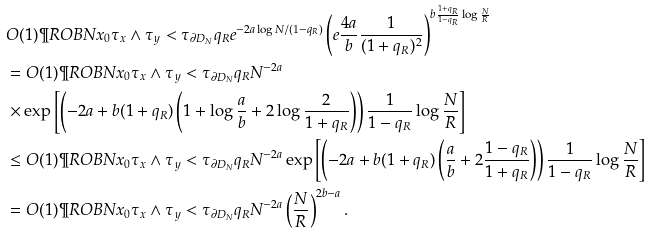<formula> <loc_0><loc_0><loc_500><loc_500>& O ( 1 ) \P R O B { N x _ { 0 } } { \tau _ { x } \wedge \tau _ { y } < \tau _ { \partial D _ { N } } } q _ { R } e ^ { - 2 a \log N / ( 1 - q _ { R } ) } \left ( e \frac { 4 a } { b } \frac { 1 } { ( 1 + q _ { R } ) ^ { 2 } } \right ) ^ { b \frac { 1 + q _ { R } } { 1 - q _ { R } } \log \frac { N } { R } } \\ & = O ( 1 ) \P R O B { N x _ { 0 } } { \tau _ { x } \wedge \tau _ { y } < \tau _ { \partial D _ { N } } } q _ { R } N ^ { - 2 a } \\ & \times \exp \left [ \left ( - 2 a + b ( 1 + q _ { R } ) \left ( 1 + \log \frac { a } { b } + 2 \log \frac { 2 } { 1 + q _ { R } } \right ) \right ) \frac { 1 } { 1 - q _ { R } } \log \frac { N } { R } \right ] \\ & \leq O ( 1 ) \P R O B { N x _ { 0 } } { \tau _ { x } \wedge \tau _ { y } < \tau _ { \partial D _ { N } } } q _ { R } N ^ { - 2 a } \exp \left [ \left ( - 2 a + b ( 1 + q _ { R } ) \left ( \frac { a } { b } + 2 \frac { 1 - q _ { R } } { 1 + q _ { R } } \right ) \right ) \frac { 1 } { 1 - q _ { R } } \log \frac { N } { R } \right ] \\ & = O ( 1 ) \P R O B { N x _ { 0 } } { \tau _ { x } \wedge \tau _ { y } < \tau _ { \partial D _ { N } } } q _ { R } N ^ { - 2 a } \left ( \frac { N } { R } \right ) ^ { 2 b - a } .</formula> 